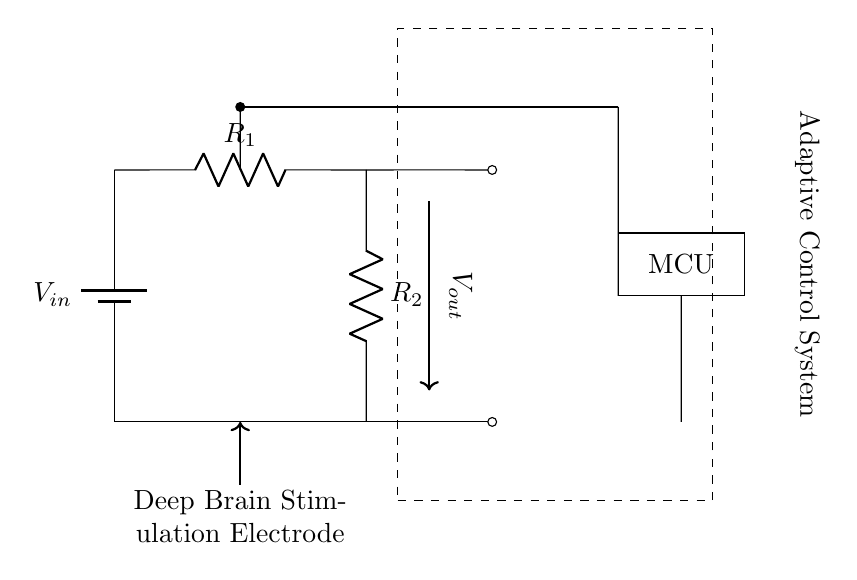What is the function of the battery in the circuit? The battery provides the input voltage, denoted as \( V_{in} \), which powers the entire circuit.
Answer: Power supply What are the two resistors labeled in the circuit? The resistors are labeled \( R_1 \) and \( R_2 \), which form the voltage divider configuration to divide the input voltage.
Answer: R1 and R2 What is the output voltage location in the circuit? The output voltage, denoted as \( V_{out} \), is taken from the junction between the two resistors \( R_1 \) and \( R_2 \) in the circuit.
Answer: Junction of R1 and R2 How does the programmable aspect work in this circuit? The circuit includes a microcontroller unit (MCU), which can adjust the resistance or the output voltage dynamically based on feedback from the adaptive control system.
Answer: Microcontroller What is the purpose of the Adaptive Control System in this design? The Adaptive Control System regulates the output based on real-time feedback, adapting the stimulation levels for therapeutic effectiveness in deep brain stimulation therapy.
Answer: Regulation of stimulation What voltage is expected at the output when \( R_1 \) is equal to \( R_2 \)? When \( R_1 = R_2 \), the output voltage \( V_{out} \) will be half of the input voltage \( V_{in} \) due to the properties of a voltage divider.
Answer: Half of Vin What role do the wires play in this circuit? The wires connect all components, allowing current to flow between the battery, resistors, MCU, and deep brain stimulation electrode, ensuring that the circuit functions as intended.
Answer: Current flow 